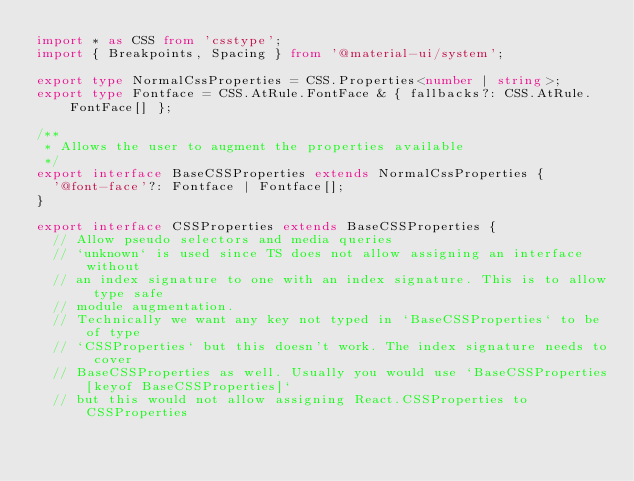Convert code to text. <code><loc_0><loc_0><loc_500><loc_500><_TypeScript_>import * as CSS from 'csstype';
import { Breakpoints, Spacing } from '@material-ui/system';

export type NormalCssProperties = CSS.Properties<number | string>;
export type Fontface = CSS.AtRule.FontFace & { fallbacks?: CSS.AtRule.FontFace[] };

/**
 * Allows the user to augment the properties available
 */
export interface BaseCSSProperties extends NormalCssProperties {
  '@font-face'?: Fontface | Fontface[];
}

export interface CSSProperties extends BaseCSSProperties {
  // Allow pseudo selectors and media queries
  // `unknown` is used since TS does not allow assigning an interface without
  // an index signature to one with an index signature. This is to allow type safe
  // module augmentation.
  // Technically we want any key not typed in `BaseCSSProperties` to be of type
  // `CSSProperties` but this doesn't work. The index signature needs to cover
  // BaseCSSProperties as well. Usually you would use `BaseCSSProperties[keyof BaseCSSProperties]`
  // but this would not allow assigning React.CSSProperties to CSSProperties</code> 